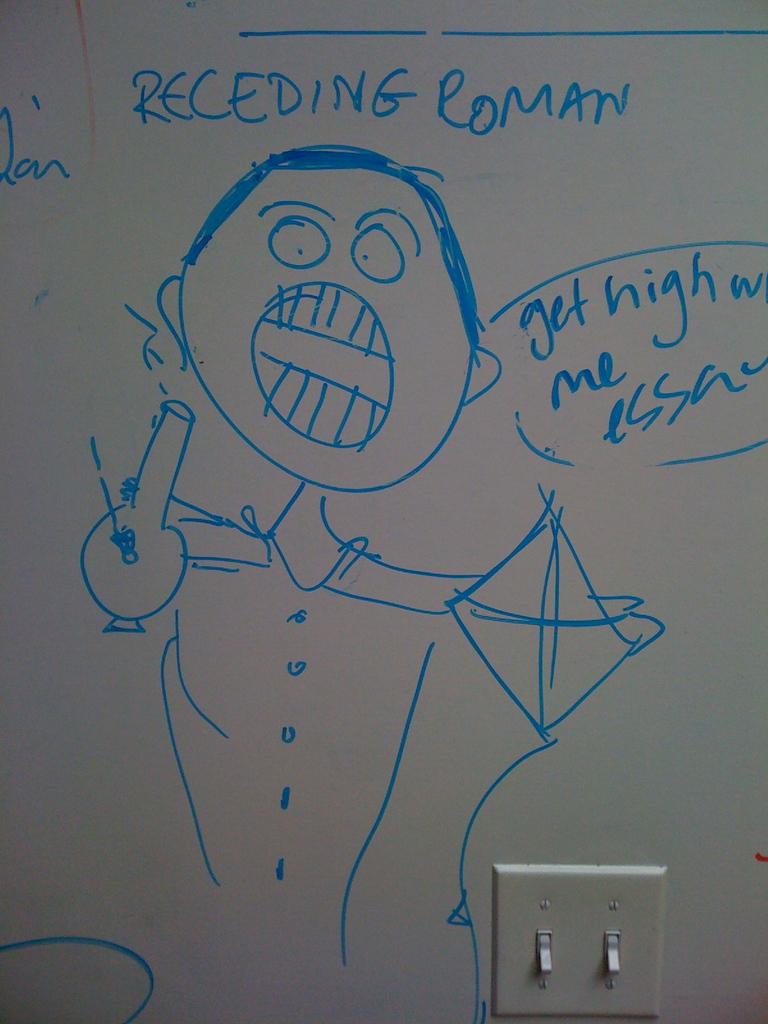What type of roman is it?
Make the answer very short. Receding. What are they suggesting?
Give a very brief answer. Get high. 